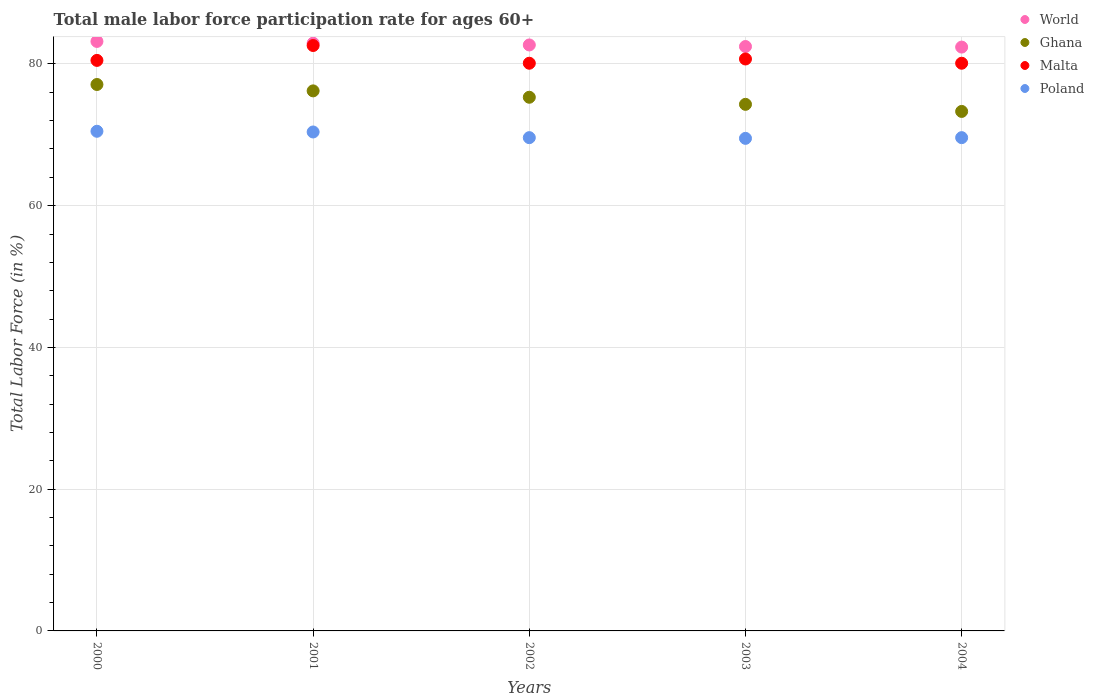Is the number of dotlines equal to the number of legend labels?
Keep it short and to the point. Yes. What is the male labor force participation rate in Poland in 2002?
Make the answer very short. 69.6. Across all years, what is the maximum male labor force participation rate in Ghana?
Provide a short and direct response. 77.1. Across all years, what is the minimum male labor force participation rate in Malta?
Provide a succinct answer. 80.1. In which year was the male labor force participation rate in Ghana minimum?
Offer a terse response. 2004. What is the total male labor force participation rate in Poland in the graph?
Your response must be concise. 349.6. What is the difference between the male labor force participation rate in Ghana in 2001 and that in 2002?
Offer a very short reply. 0.9. What is the difference between the male labor force participation rate in World in 2004 and the male labor force participation rate in Ghana in 2003?
Ensure brevity in your answer.  8.08. What is the average male labor force participation rate in Poland per year?
Your answer should be compact. 69.92. In the year 2001, what is the difference between the male labor force participation rate in Malta and male labor force participation rate in Poland?
Ensure brevity in your answer.  12.2. In how many years, is the male labor force participation rate in Ghana greater than 4 %?
Your answer should be compact. 5. What is the ratio of the male labor force participation rate in Ghana in 2003 to that in 2004?
Offer a very short reply. 1.01. What is the difference between the highest and the second highest male labor force participation rate in Poland?
Provide a succinct answer. 0.1. What is the difference between the highest and the lowest male labor force participation rate in Malta?
Provide a succinct answer. 2.5. Is it the case that in every year, the sum of the male labor force participation rate in Ghana and male labor force participation rate in Poland  is greater than the sum of male labor force participation rate in Malta and male labor force participation rate in World?
Provide a short and direct response. Yes. How many dotlines are there?
Ensure brevity in your answer.  4. What is the difference between two consecutive major ticks on the Y-axis?
Offer a very short reply. 20. Are the values on the major ticks of Y-axis written in scientific E-notation?
Provide a succinct answer. No. Does the graph contain any zero values?
Make the answer very short. No. Where does the legend appear in the graph?
Offer a very short reply. Top right. How many legend labels are there?
Give a very brief answer. 4. How are the legend labels stacked?
Ensure brevity in your answer.  Vertical. What is the title of the graph?
Keep it short and to the point. Total male labor force participation rate for ages 60+. What is the label or title of the Y-axis?
Your response must be concise. Total Labor Force (in %). What is the Total Labor Force (in %) of World in 2000?
Offer a very short reply. 83.18. What is the Total Labor Force (in %) of Ghana in 2000?
Your answer should be very brief. 77.1. What is the Total Labor Force (in %) in Malta in 2000?
Offer a terse response. 80.5. What is the Total Labor Force (in %) of Poland in 2000?
Keep it short and to the point. 70.5. What is the Total Labor Force (in %) in World in 2001?
Ensure brevity in your answer.  82.93. What is the Total Labor Force (in %) in Ghana in 2001?
Offer a very short reply. 76.2. What is the Total Labor Force (in %) of Malta in 2001?
Make the answer very short. 82.6. What is the Total Labor Force (in %) in Poland in 2001?
Give a very brief answer. 70.4. What is the Total Labor Force (in %) of World in 2002?
Your response must be concise. 82.68. What is the Total Labor Force (in %) in Ghana in 2002?
Give a very brief answer. 75.3. What is the Total Labor Force (in %) in Malta in 2002?
Offer a terse response. 80.1. What is the Total Labor Force (in %) of Poland in 2002?
Ensure brevity in your answer.  69.6. What is the Total Labor Force (in %) in World in 2003?
Make the answer very short. 82.46. What is the Total Labor Force (in %) of Ghana in 2003?
Your response must be concise. 74.3. What is the Total Labor Force (in %) of Malta in 2003?
Make the answer very short. 80.7. What is the Total Labor Force (in %) in Poland in 2003?
Make the answer very short. 69.5. What is the Total Labor Force (in %) of World in 2004?
Ensure brevity in your answer.  82.38. What is the Total Labor Force (in %) in Ghana in 2004?
Provide a succinct answer. 73.3. What is the Total Labor Force (in %) in Malta in 2004?
Your answer should be very brief. 80.1. What is the Total Labor Force (in %) of Poland in 2004?
Offer a terse response. 69.6. Across all years, what is the maximum Total Labor Force (in %) of World?
Make the answer very short. 83.18. Across all years, what is the maximum Total Labor Force (in %) of Ghana?
Your answer should be very brief. 77.1. Across all years, what is the maximum Total Labor Force (in %) of Malta?
Offer a terse response. 82.6. Across all years, what is the maximum Total Labor Force (in %) in Poland?
Ensure brevity in your answer.  70.5. Across all years, what is the minimum Total Labor Force (in %) of World?
Your answer should be very brief. 82.38. Across all years, what is the minimum Total Labor Force (in %) of Ghana?
Ensure brevity in your answer.  73.3. Across all years, what is the minimum Total Labor Force (in %) of Malta?
Make the answer very short. 80.1. Across all years, what is the minimum Total Labor Force (in %) of Poland?
Provide a succinct answer. 69.5. What is the total Total Labor Force (in %) in World in the graph?
Offer a very short reply. 413.62. What is the total Total Labor Force (in %) in Ghana in the graph?
Offer a very short reply. 376.2. What is the total Total Labor Force (in %) of Malta in the graph?
Your answer should be compact. 404. What is the total Total Labor Force (in %) of Poland in the graph?
Provide a short and direct response. 349.6. What is the difference between the Total Labor Force (in %) in World in 2000 and that in 2001?
Give a very brief answer. 0.25. What is the difference between the Total Labor Force (in %) of Ghana in 2000 and that in 2001?
Your answer should be compact. 0.9. What is the difference between the Total Labor Force (in %) of Poland in 2000 and that in 2001?
Give a very brief answer. 0.1. What is the difference between the Total Labor Force (in %) of World in 2000 and that in 2002?
Offer a terse response. 0.5. What is the difference between the Total Labor Force (in %) of Ghana in 2000 and that in 2002?
Offer a very short reply. 1.8. What is the difference between the Total Labor Force (in %) in Poland in 2000 and that in 2002?
Your response must be concise. 0.9. What is the difference between the Total Labor Force (in %) of World in 2000 and that in 2003?
Provide a short and direct response. 0.72. What is the difference between the Total Labor Force (in %) of Malta in 2000 and that in 2003?
Offer a very short reply. -0.2. What is the difference between the Total Labor Force (in %) in Poland in 2000 and that in 2003?
Ensure brevity in your answer.  1. What is the difference between the Total Labor Force (in %) in World in 2000 and that in 2004?
Your answer should be compact. 0.8. What is the difference between the Total Labor Force (in %) in Poland in 2000 and that in 2004?
Make the answer very short. 0.9. What is the difference between the Total Labor Force (in %) in World in 2001 and that in 2002?
Your response must be concise. 0.25. What is the difference between the Total Labor Force (in %) of Ghana in 2001 and that in 2002?
Offer a very short reply. 0.9. What is the difference between the Total Labor Force (in %) of World in 2001 and that in 2003?
Offer a terse response. 0.47. What is the difference between the Total Labor Force (in %) in Ghana in 2001 and that in 2003?
Offer a very short reply. 1.9. What is the difference between the Total Labor Force (in %) of Malta in 2001 and that in 2003?
Provide a succinct answer. 1.9. What is the difference between the Total Labor Force (in %) in World in 2001 and that in 2004?
Give a very brief answer. 0.55. What is the difference between the Total Labor Force (in %) of Ghana in 2001 and that in 2004?
Ensure brevity in your answer.  2.9. What is the difference between the Total Labor Force (in %) in Malta in 2001 and that in 2004?
Offer a terse response. 2.5. What is the difference between the Total Labor Force (in %) of Poland in 2001 and that in 2004?
Your answer should be very brief. 0.8. What is the difference between the Total Labor Force (in %) of World in 2002 and that in 2003?
Your answer should be very brief. 0.22. What is the difference between the Total Labor Force (in %) of Ghana in 2002 and that in 2003?
Offer a terse response. 1. What is the difference between the Total Labor Force (in %) of Poland in 2002 and that in 2003?
Your answer should be compact. 0.1. What is the difference between the Total Labor Force (in %) of World in 2002 and that in 2004?
Provide a short and direct response. 0.3. What is the difference between the Total Labor Force (in %) in Ghana in 2002 and that in 2004?
Make the answer very short. 2. What is the difference between the Total Labor Force (in %) of World in 2003 and that in 2004?
Your response must be concise. 0.08. What is the difference between the Total Labor Force (in %) of Ghana in 2003 and that in 2004?
Make the answer very short. 1. What is the difference between the Total Labor Force (in %) of Malta in 2003 and that in 2004?
Make the answer very short. 0.6. What is the difference between the Total Labor Force (in %) in World in 2000 and the Total Labor Force (in %) in Ghana in 2001?
Make the answer very short. 6.98. What is the difference between the Total Labor Force (in %) in World in 2000 and the Total Labor Force (in %) in Malta in 2001?
Provide a short and direct response. 0.58. What is the difference between the Total Labor Force (in %) of World in 2000 and the Total Labor Force (in %) of Poland in 2001?
Ensure brevity in your answer.  12.78. What is the difference between the Total Labor Force (in %) in Ghana in 2000 and the Total Labor Force (in %) in Malta in 2001?
Provide a succinct answer. -5.5. What is the difference between the Total Labor Force (in %) in Ghana in 2000 and the Total Labor Force (in %) in Poland in 2001?
Ensure brevity in your answer.  6.7. What is the difference between the Total Labor Force (in %) in World in 2000 and the Total Labor Force (in %) in Ghana in 2002?
Ensure brevity in your answer.  7.88. What is the difference between the Total Labor Force (in %) of World in 2000 and the Total Labor Force (in %) of Malta in 2002?
Provide a succinct answer. 3.08. What is the difference between the Total Labor Force (in %) of World in 2000 and the Total Labor Force (in %) of Poland in 2002?
Give a very brief answer. 13.58. What is the difference between the Total Labor Force (in %) of Ghana in 2000 and the Total Labor Force (in %) of Malta in 2002?
Provide a short and direct response. -3. What is the difference between the Total Labor Force (in %) in Ghana in 2000 and the Total Labor Force (in %) in Poland in 2002?
Your answer should be compact. 7.5. What is the difference between the Total Labor Force (in %) of Malta in 2000 and the Total Labor Force (in %) of Poland in 2002?
Provide a short and direct response. 10.9. What is the difference between the Total Labor Force (in %) of World in 2000 and the Total Labor Force (in %) of Ghana in 2003?
Your answer should be very brief. 8.88. What is the difference between the Total Labor Force (in %) of World in 2000 and the Total Labor Force (in %) of Malta in 2003?
Ensure brevity in your answer.  2.48. What is the difference between the Total Labor Force (in %) in World in 2000 and the Total Labor Force (in %) in Poland in 2003?
Provide a short and direct response. 13.68. What is the difference between the Total Labor Force (in %) in Ghana in 2000 and the Total Labor Force (in %) in Poland in 2003?
Keep it short and to the point. 7.6. What is the difference between the Total Labor Force (in %) in World in 2000 and the Total Labor Force (in %) in Ghana in 2004?
Your response must be concise. 9.88. What is the difference between the Total Labor Force (in %) in World in 2000 and the Total Labor Force (in %) in Malta in 2004?
Make the answer very short. 3.08. What is the difference between the Total Labor Force (in %) of World in 2000 and the Total Labor Force (in %) of Poland in 2004?
Your response must be concise. 13.58. What is the difference between the Total Labor Force (in %) in Ghana in 2000 and the Total Labor Force (in %) in Malta in 2004?
Offer a terse response. -3. What is the difference between the Total Labor Force (in %) in Ghana in 2000 and the Total Labor Force (in %) in Poland in 2004?
Offer a terse response. 7.5. What is the difference between the Total Labor Force (in %) in Malta in 2000 and the Total Labor Force (in %) in Poland in 2004?
Make the answer very short. 10.9. What is the difference between the Total Labor Force (in %) in World in 2001 and the Total Labor Force (in %) in Ghana in 2002?
Ensure brevity in your answer.  7.63. What is the difference between the Total Labor Force (in %) of World in 2001 and the Total Labor Force (in %) of Malta in 2002?
Make the answer very short. 2.83. What is the difference between the Total Labor Force (in %) of World in 2001 and the Total Labor Force (in %) of Poland in 2002?
Your answer should be compact. 13.33. What is the difference between the Total Labor Force (in %) in Malta in 2001 and the Total Labor Force (in %) in Poland in 2002?
Give a very brief answer. 13. What is the difference between the Total Labor Force (in %) of World in 2001 and the Total Labor Force (in %) of Ghana in 2003?
Make the answer very short. 8.63. What is the difference between the Total Labor Force (in %) in World in 2001 and the Total Labor Force (in %) in Malta in 2003?
Provide a short and direct response. 2.23. What is the difference between the Total Labor Force (in %) in World in 2001 and the Total Labor Force (in %) in Poland in 2003?
Your answer should be very brief. 13.43. What is the difference between the Total Labor Force (in %) in World in 2001 and the Total Labor Force (in %) in Ghana in 2004?
Your response must be concise. 9.63. What is the difference between the Total Labor Force (in %) of World in 2001 and the Total Labor Force (in %) of Malta in 2004?
Your response must be concise. 2.83. What is the difference between the Total Labor Force (in %) in World in 2001 and the Total Labor Force (in %) in Poland in 2004?
Your answer should be compact. 13.33. What is the difference between the Total Labor Force (in %) in Ghana in 2001 and the Total Labor Force (in %) in Malta in 2004?
Keep it short and to the point. -3.9. What is the difference between the Total Labor Force (in %) of Ghana in 2001 and the Total Labor Force (in %) of Poland in 2004?
Make the answer very short. 6.6. What is the difference between the Total Labor Force (in %) of Malta in 2001 and the Total Labor Force (in %) of Poland in 2004?
Offer a terse response. 13. What is the difference between the Total Labor Force (in %) of World in 2002 and the Total Labor Force (in %) of Ghana in 2003?
Offer a terse response. 8.38. What is the difference between the Total Labor Force (in %) of World in 2002 and the Total Labor Force (in %) of Malta in 2003?
Provide a short and direct response. 1.98. What is the difference between the Total Labor Force (in %) of World in 2002 and the Total Labor Force (in %) of Poland in 2003?
Your answer should be compact. 13.18. What is the difference between the Total Labor Force (in %) in Malta in 2002 and the Total Labor Force (in %) in Poland in 2003?
Make the answer very short. 10.6. What is the difference between the Total Labor Force (in %) of World in 2002 and the Total Labor Force (in %) of Ghana in 2004?
Provide a succinct answer. 9.38. What is the difference between the Total Labor Force (in %) in World in 2002 and the Total Labor Force (in %) in Malta in 2004?
Ensure brevity in your answer.  2.58. What is the difference between the Total Labor Force (in %) of World in 2002 and the Total Labor Force (in %) of Poland in 2004?
Your answer should be compact. 13.08. What is the difference between the Total Labor Force (in %) in Ghana in 2002 and the Total Labor Force (in %) in Malta in 2004?
Offer a terse response. -4.8. What is the difference between the Total Labor Force (in %) of Ghana in 2002 and the Total Labor Force (in %) of Poland in 2004?
Your answer should be very brief. 5.7. What is the difference between the Total Labor Force (in %) of World in 2003 and the Total Labor Force (in %) of Ghana in 2004?
Provide a short and direct response. 9.16. What is the difference between the Total Labor Force (in %) of World in 2003 and the Total Labor Force (in %) of Malta in 2004?
Offer a very short reply. 2.36. What is the difference between the Total Labor Force (in %) of World in 2003 and the Total Labor Force (in %) of Poland in 2004?
Give a very brief answer. 12.86. What is the difference between the Total Labor Force (in %) in Ghana in 2003 and the Total Labor Force (in %) in Malta in 2004?
Your answer should be compact. -5.8. What is the average Total Labor Force (in %) of World per year?
Provide a succinct answer. 82.72. What is the average Total Labor Force (in %) of Ghana per year?
Offer a very short reply. 75.24. What is the average Total Labor Force (in %) in Malta per year?
Offer a very short reply. 80.8. What is the average Total Labor Force (in %) in Poland per year?
Make the answer very short. 69.92. In the year 2000, what is the difference between the Total Labor Force (in %) of World and Total Labor Force (in %) of Ghana?
Give a very brief answer. 6.08. In the year 2000, what is the difference between the Total Labor Force (in %) in World and Total Labor Force (in %) in Malta?
Give a very brief answer. 2.68. In the year 2000, what is the difference between the Total Labor Force (in %) of World and Total Labor Force (in %) of Poland?
Provide a succinct answer. 12.68. In the year 2000, what is the difference between the Total Labor Force (in %) in Ghana and Total Labor Force (in %) in Poland?
Offer a very short reply. 6.6. In the year 2000, what is the difference between the Total Labor Force (in %) of Malta and Total Labor Force (in %) of Poland?
Make the answer very short. 10. In the year 2001, what is the difference between the Total Labor Force (in %) in World and Total Labor Force (in %) in Ghana?
Offer a terse response. 6.73. In the year 2001, what is the difference between the Total Labor Force (in %) of World and Total Labor Force (in %) of Malta?
Keep it short and to the point. 0.33. In the year 2001, what is the difference between the Total Labor Force (in %) in World and Total Labor Force (in %) in Poland?
Offer a very short reply. 12.53. In the year 2001, what is the difference between the Total Labor Force (in %) in Ghana and Total Labor Force (in %) in Malta?
Your answer should be compact. -6.4. In the year 2002, what is the difference between the Total Labor Force (in %) in World and Total Labor Force (in %) in Ghana?
Your response must be concise. 7.38. In the year 2002, what is the difference between the Total Labor Force (in %) of World and Total Labor Force (in %) of Malta?
Keep it short and to the point. 2.58. In the year 2002, what is the difference between the Total Labor Force (in %) in World and Total Labor Force (in %) in Poland?
Provide a succinct answer. 13.08. In the year 2002, what is the difference between the Total Labor Force (in %) of Ghana and Total Labor Force (in %) of Malta?
Make the answer very short. -4.8. In the year 2003, what is the difference between the Total Labor Force (in %) of World and Total Labor Force (in %) of Ghana?
Your answer should be compact. 8.16. In the year 2003, what is the difference between the Total Labor Force (in %) in World and Total Labor Force (in %) in Malta?
Provide a short and direct response. 1.76. In the year 2003, what is the difference between the Total Labor Force (in %) in World and Total Labor Force (in %) in Poland?
Your response must be concise. 12.96. In the year 2004, what is the difference between the Total Labor Force (in %) in World and Total Labor Force (in %) in Ghana?
Provide a succinct answer. 9.08. In the year 2004, what is the difference between the Total Labor Force (in %) in World and Total Labor Force (in %) in Malta?
Give a very brief answer. 2.28. In the year 2004, what is the difference between the Total Labor Force (in %) in World and Total Labor Force (in %) in Poland?
Your answer should be compact. 12.78. In the year 2004, what is the difference between the Total Labor Force (in %) in Ghana and Total Labor Force (in %) in Malta?
Ensure brevity in your answer.  -6.8. In the year 2004, what is the difference between the Total Labor Force (in %) of Malta and Total Labor Force (in %) of Poland?
Ensure brevity in your answer.  10.5. What is the ratio of the Total Labor Force (in %) in World in 2000 to that in 2001?
Provide a succinct answer. 1. What is the ratio of the Total Labor Force (in %) of Ghana in 2000 to that in 2001?
Your response must be concise. 1.01. What is the ratio of the Total Labor Force (in %) of Malta in 2000 to that in 2001?
Your answer should be compact. 0.97. What is the ratio of the Total Labor Force (in %) in World in 2000 to that in 2002?
Provide a short and direct response. 1.01. What is the ratio of the Total Labor Force (in %) of Ghana in 2000 to that in 2002?
Give a very brief answer. 1.02. What is the ratio of the Total Labor Force (in %) in Poland in 2000 to that in 2002?
Offer a very short reply. 1.01. What is the ratio of the Total Labor Force (in %) in World in 2000 to that in 2003?
Provide a succinct answer. 1.01. What is the ratio of the Total Labor Force (in %) of Ghana in 2000 to that in 2003?
Ensure brevity in your answer.  1.04. What is the ratio of the Total Labor Force (in %) in Poland in 2000 to that in 2003?
Offer a terse response. 1.01. What is the ratio of the Total Labor Force (in %) in World in 2000 to that in 2004?
Your response must be concise. 1.01. What is the ratio of the Total Labor Force (in %) of Ghana in 2000 to that in 2004?
Provide a short and direct response. 1.05. What is the ratio of the Total Labor Force (in %) of Malta in 2000 to that in 2004?
Give a very brief answer. 1. What is the ratio of the Total Labor Force (in %) of Poland in 2000 to that in 2004?
Offer a terse response. 1.01. What is the ratio of the Total Labor Force (in %) in Malta in 2001 to that in 2002?
Provide a short and direct response. 1.03. What is the ratio of the Total Labor Force (in %) in Poland in 2001 to that in 2002?
Make the answer very short. 1.01. What is the ratio of the Total Labor Force (in %) in Ghana in 2001 to that in 2003?
Ensure brevity in your answer.  1.03. What is the ratio of the Total Labor Force (in %) of Malta in 2001 to that in 2003?
Your answer should be compact. 1.02. What is the ratio of the Total Labor Force (in %) in Poland in 2001 to that in 2003?
Make the answer very short. 1.01. What is the ratio of the Total Labor Force (in %) in World in 2001 to that in 2004?
Your answer should be very brief. 1.01. What is the ratio of the Total Labor Force (in %) in Ghana in 2001 to that in 2004?
Offer a terse response. 1.04. What is the ratio of the Total Labor Force (in %) of Malta in 2001 to that in 2004?
Your answer should be compact. 1.03. What is the ratio of the Total Labor Force (in %) of Poland in 2001 to that in 2004?
Give a very brief answer. 1.01. What is the ratio of the Total Labor Force (in %) of Ghana in 2002 to that in 2003?
Your response must be concise. 1.01. What is the ratio of the Total Labor Force (in %) of Malta in 2002 to that in 2003?
Offer a terse response. 0.99. What is the ratio of the Total Labor Force (in %) of Poland in 2002 to that in 2003?
Make the answer very short. 1. What is the ratio of the Total Labor Force (in %) of World in 2002 to that in 2004?
Your response must be concise. 1. What is the ratio of the Total Labor Force (in %) in Ghana in 2002 to that in 2004?
Your answer should be compact. 1.03. What is the ratio of the Total Labor Force (in %) in Malta in 2002 to that in 2004?
Your answer should be compact. 1. What is the ratio of the Total Labor Force (in %) of World in 2003 to that in 2004?
Provide a succinct answer. 1. What is the ratio of the Total Labor Force (in %) in Ghana in 2003 to that in 2004?
Give a very brief answer. 1.01. What is the ratio of the Total Labor Force (in %) of Malta in 2003 to that in 2004?
Offer a terse response. 1.01. What is the difference between the highest and the second highest Total Labor Force (in %) in World?
Provide a succinct answer. 0.25. What is the difference between the highest and the second highest Total Labor Force (in %) in Ghana?
Your answer should be very brief. 0.9. What is the difference between the highest and the lowest Total Labor Force (in %) in World?
Make the answer very short. 0.8. What is the difference between the highest and the lowest Total Labor Force (in %) of Malta?
Offer a terse response. 2.5. 